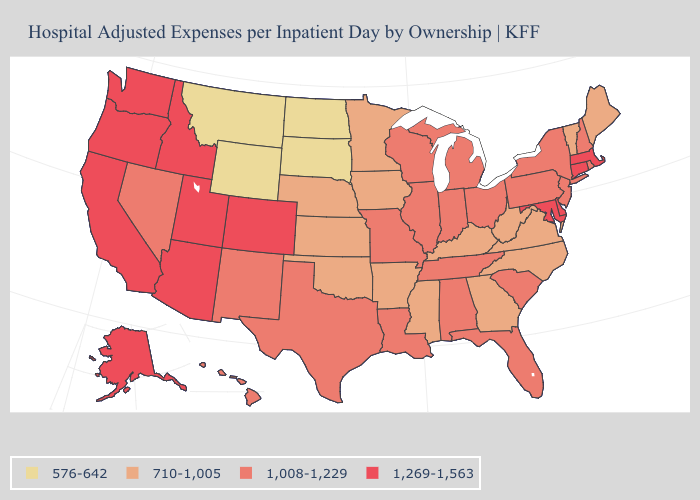What is the highest value in the USA?
Short answer required. 1,269-1,563. Name the states that have a value in the range 1,008-1,229?
Keep it brief. Alabama, Florida, Hawaii, Illinois, Indiana, Louisiana, Michigan, Missouri, Nevada, New Hampshire, New Jersey, New Mexico, New York, Ohio, Pennsylvania, Rhode Island, South Carolina, Tennessee, Texas, Wisconsin. What is the value of Wyoming?
Give a very brief answer. 576-642. Name the states that have a value in the range 710-1,005?
Quick response, please. Arkansas, Georgia, Iowa, Kansas, Kentucky, Maine, Minnesota, Mississippi, Nebraska, North Carolina, Oklahoma, Vermont, Virginia, West Virginia. How many symbols are there in the legend?
Quick response, please. 4. Name the states that have a value in the range 1,008-1,229?
Short answer required. Alabama, Florida, Hawaii, Illinois, Indiana, Louisiana, Michigan, Missouri, Nevada, New Hampshire, New Jersey, New Mexico, New York, Ohio, Pennsylvania, Rhode Island, South Carolina, Tennessee, Texas, Wisconsin. What is the lowest value in the USA?
Answer briefly. 576-642. How many symbols are there in the legend?
Short answer required. 4. What is the lowest value in the USA?
Answer briefly. 576-642. What is the value of Wyoming?
Give a very brief answer. 576-642. Name the states that have a value in the range 1,008-1,229?
Keep it brief. Alabama, Florida, Hawaii, Illinois, Indiana, Louisiana, Michigan, Missouri, Nevada, New Hampshire, New Jersey, New Mexico, New York, Ohio, Pennsylvania, Rhode Island, South Carolina, Tennessee, Texas, Wisconsin. Among the states that border Wyoming , which have the lowest value?
Answer briefly. Montana, South Dakota. Does Minnesota have the highest value in the MidWest?
Concise answer only. No. Which states have the lowest value in the South?
Keep it brief. Arkansas, Georgia, Kentucky, Mississippi, North Carolina, Oklahoma, Virginia, West Virginia. 